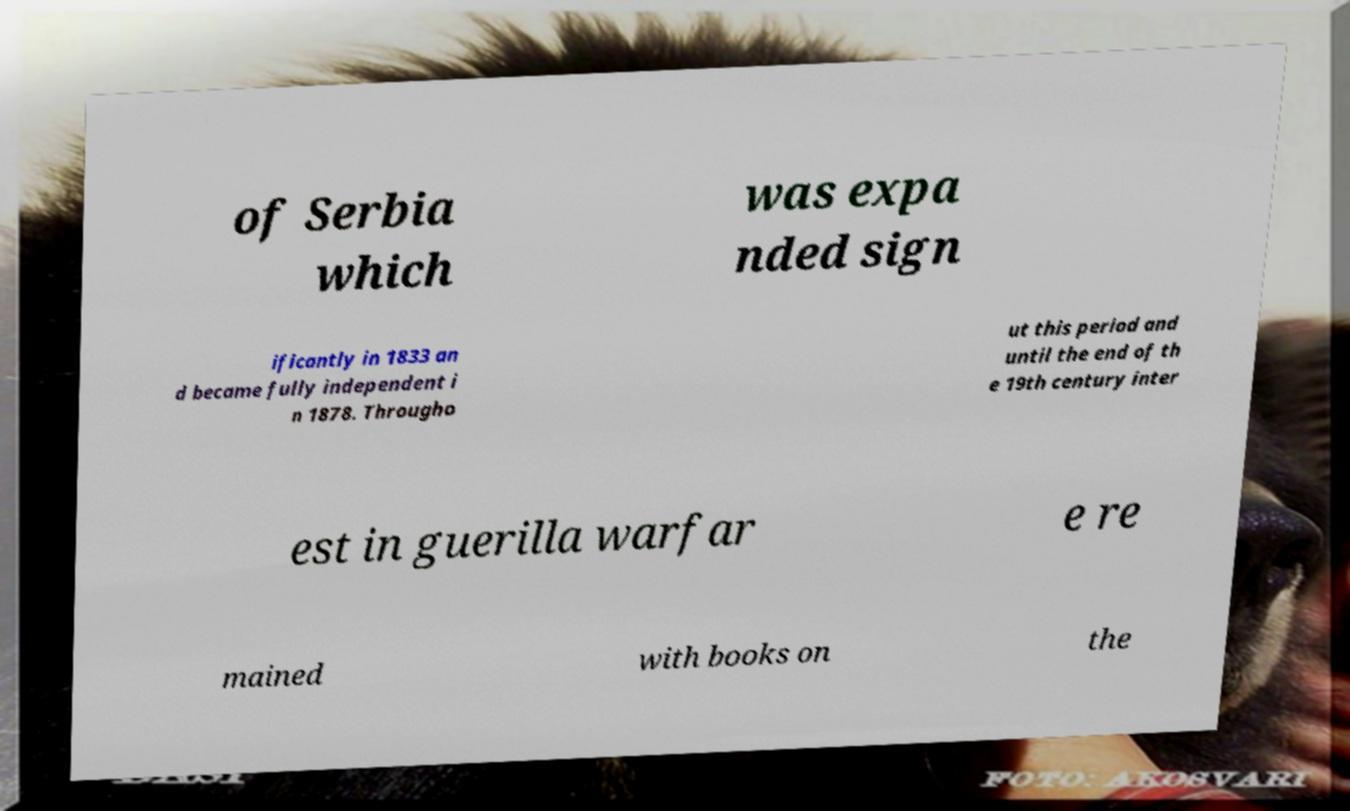Can you accurately transcribe the text from the provided image for me? of Serbia which was expa nded sign ificantly in 1833 an d became fully independent i n 1878. Througho ut this period and until the end of th e 19th century inter est in guerilla warfar e re mained with books on the 